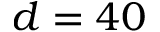<formula> <loc_0><loc_0><loc_500><loc_500>d = 4 0</formula> 